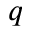<formula> <loc_0><loc_0><loc_500><loc_500>q</formula> 